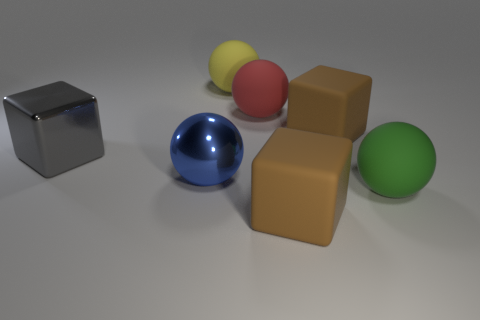Is there anything in the image that indicates the size of these objects? The image doesn't include a specific reference object to indicate the absolute size of the objects, but relative to each other, the spheres and cubes appear to be similar in size, suggesting they might be small, handheld objects. 